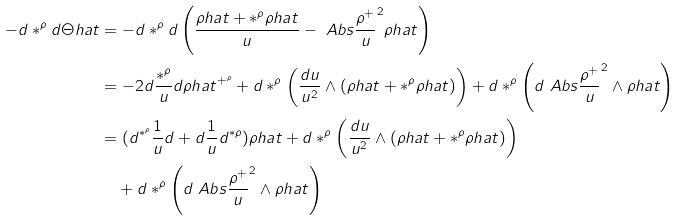Convert formula to latex. <formula><loc_0><loc_0><loc_500><loc_500>- d * ^ { \rho } d \Theta h a t & = - d * ^ { \rho } d \left ( \frac { \rho h a t + * ^ { \rho } \rho h a t } { u } - \ A b s { \frac { \rho ^ { + } } { u } } ^ { 2 } \rho h a t \right ) \\ & = - 2 d \frac { * ^ { \rho } } { u } d \rho h a t ^ { + ^ { \rho } } + d * ^ { \rho } \left ( \frac { d u } { u ^ { 2 } } \wedge ( \rho h a t + * ^ { \rho } \rho h a t ) \right ) + d * ^ { \rho } \left ( d \ A b s { \frac { \rho ^ { + } } { u } } ^ { 2 } \wedge \rho h a t \right ) \\ & = ( d ^ { * ^ { \rho } } \frac { 1 } { u } d + d \frac { 1 } { u } d ^ { * \rho } ) \rho h a t + d * ^ { \rho } \left ( \frac { d u } { u ^ { 2 } } \wedge ( \rho h a t + * ^ { \rho } \rho h a t ) \right ) \\ & \quad + d * ^ { \rho } \left ( d \ A b s { \frac { \rho ^ { + } } { u } } ^ { 2 } \wedge \rho h a t \right )</formula> 